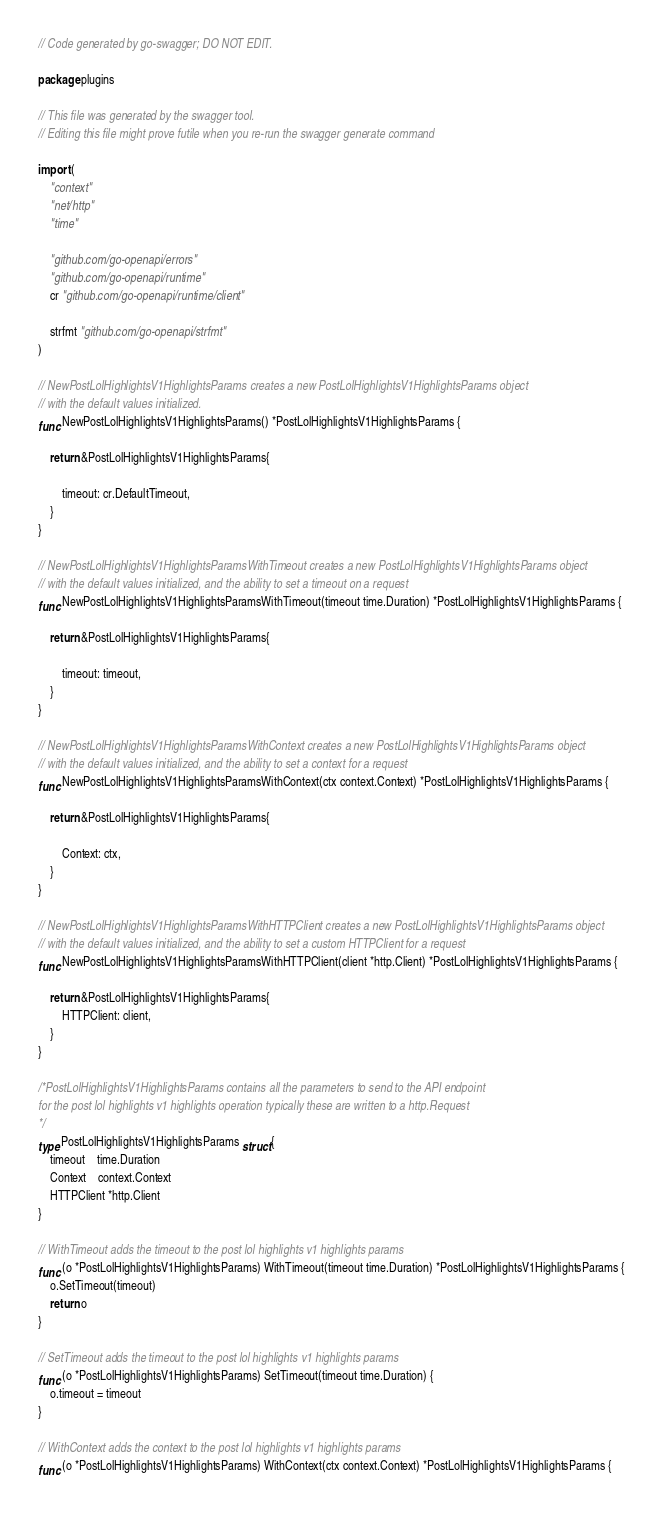<code> <loc_0><loc_0><loc_500><loc_500><_Go_>// Code generated by go-swagger; DO NOT EDIT.

package plugins

// This file was generated by the swagger tool.
// Editing this file might prove futile when you re-run the swagger generate command

import (
	"context"
	"net/http"
	"time"

	"github.com/go-openapi/errors"
	"github.com/go-openapi/runtime"
	cr "github.com/go-openapi/runtime/client"

	strfmt "github.com/go-openapi/strfmt"
)

// NewPostLolHighlightsV1HighlightsParams creates a new PostLolHighlightsV1HighlightsParams object
// with the default values initialized.
func NewPostLolHighlightsV1HighlightsParams() *PostLolHighlightsV1HighlightsParams {

	return &PostLolHighlightsV1HighlightsParams{

		timeout: cr.DefaultTimeout,
	}
}

// NewPostLolHighlightsV1HighlightsParamsWithTimeout creates a new PostLolHighlightsV1HighlightsParams object
// with the default values initialized, and the ability to set a timeout on a request
func NewPostLolHighlightsV1HighlightsParamsWithTimeout(timeout time.Duration) *PostLolHighlightsV1HighlightsParams {

	return &PostLolHighlightsV1HighlightsParams{

		timeout: timeout,
	}
}

// NewPostLolHighlightsV1HighlightsParamsWithContext creates a new PostLolHighlightsV1HighlightsParams object
// with the default values initialized, and the ability to set a context for a request
func NewPostLolHighlightsV1HighlightsParamsWithContext(ctx context.Context) *PostLolHighlightsV1HighlightsParams {

	return &PostLolHighlightsV1HighlightsParams{

		Context: ctx,
	}
}

// NewPostLolHighlightsV1HighlightsParamsWithHTTPClient creates a new PostLolHighlightsV1HighlightsParams object
// with the default values initialized, and the ability to set a custom HTTPClient for a request
func NewPostLolHighlightsV1HighlightsParamsWithHTTPClient(client *http.Client) *PostLolHighlightsV1HighlightsParams {

	return &PostLolHighlightsV1HighlightsParams{
		HTTPClient: client,
	}
}

/*PostLolHighlightsV1HighlightsParams contains all the parameters to send to the API endpoint
for the post lol highlights v1 highlights operation typically these are written to a http.Request
*/
type PostLolHighlightsV1HighlightsParams struct {
	timeout    time.Duration
	Context    context.Context
	HTTPClient *http.Client
}

// WithTimeout adds the timeout to the post lol highlights v1 highlights params
func (o *PostLolHighlightsV1HighlightsParams) WithTimeout(timeout time.Duration) *PostLolHighlightsV1HighlightsParams {
	o.SetTimeout(timeout)
	return o
}

// SetTimeout adds the timeout to the post lol highlights v1 highlights params
func (o *PostLolHighlightsV1HighlightsParams) SetTimeout(timeout time.Duration) {
	o.timeout = timeout
}

// WithContext adds the context to the post lol highlights v1 highlights params
func (o *PostLolHighlightsV1HighlightsParams) WithContext(ctx context.Context) *PostLolHighlightsV1HighlightsParams {</code> 